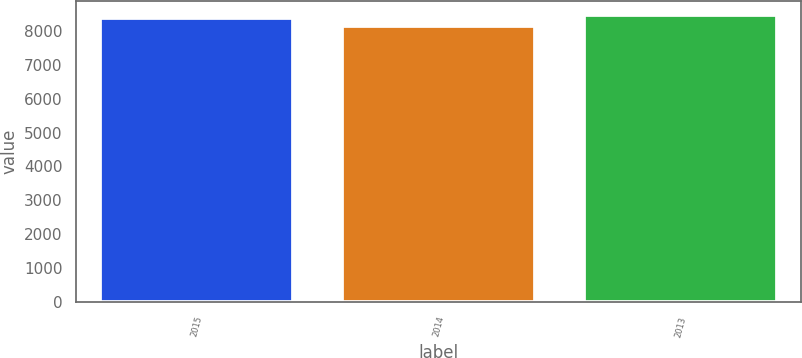<chart> <loc_0><loc_0><loc_500><loc_500><bar_chart><fcel>2015<fcel>2014<fcel>2013<nl><fcel>8390<fcel>8148<fcel>8466<nl></chart> 